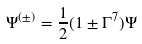<formula> <loc_0><loc_0><loc_500><loc_500>\Psi ^ { ( \pm ) } = \frac { 1 } { 2 } ( 1 \pm \Gamma ^ { 7 } ) \Psi</formula> 